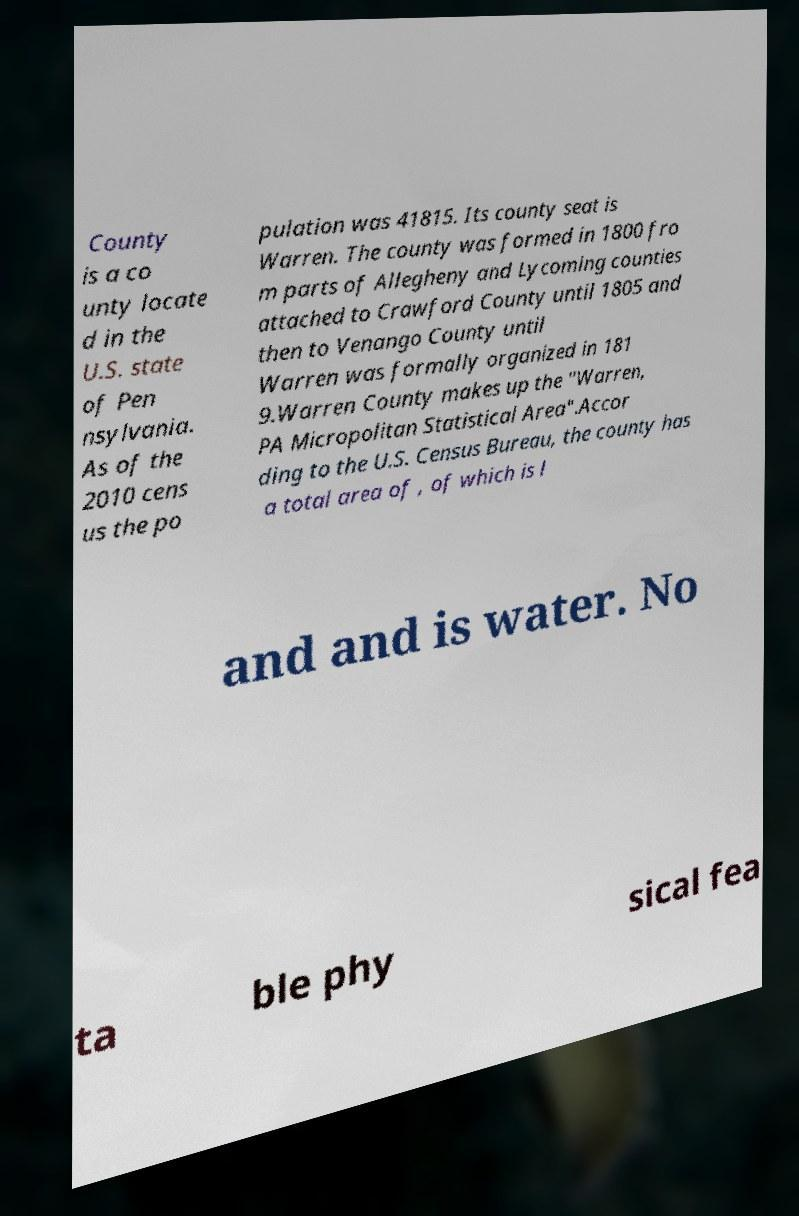Can you accurately transcribe the text from the provided image for me? County is a co unty locate d in the U.S. state of Pen nsylvania. As of the 2010 cens us the po pulation was 41815. Its county seat is Warren. The county was formed in 1800 fro m parts of Allegheny and Lycoming counties attached to Crawford County until 1805 and then to Venango County until Warren was formally organized in 181 9.Warren County makes up the "Warren, PA Micropolitan Statistical Area".Accor ding to the U.S. Census Bureau, the county has a total area of , of which is l and and is water. No ta ble phy sical fea 